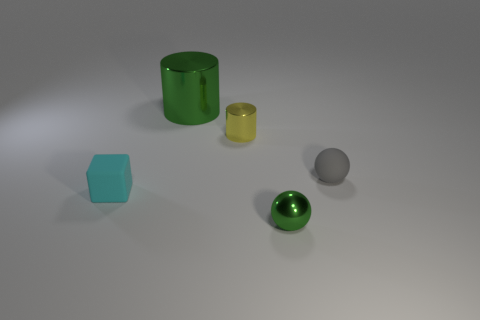Subtract 1 cylinders. How many cylinders are left? 1 Add 1 gray matte balls. How many objects exist? 6 Subtract all gray balls. How many balls are left? 1 Subtract all cylinders. How many objects are left? 3 Subtract all gray blocks. How many green cylinders are left? 1 Subtract all red cylinders. Subtract all cyan balls. How many cylinders are left? 2 Add 3 metallic cylinders. How many metallic cylinders exist? 5 Subtract 0 purple cylinders. How many objects are left? 5 Subtract all tiny metallic cylinders. Subtract all big green shiny cylinders. How many objects are left? 3 Add 4 large green cylinders. How many large green cylinders are left? 5 